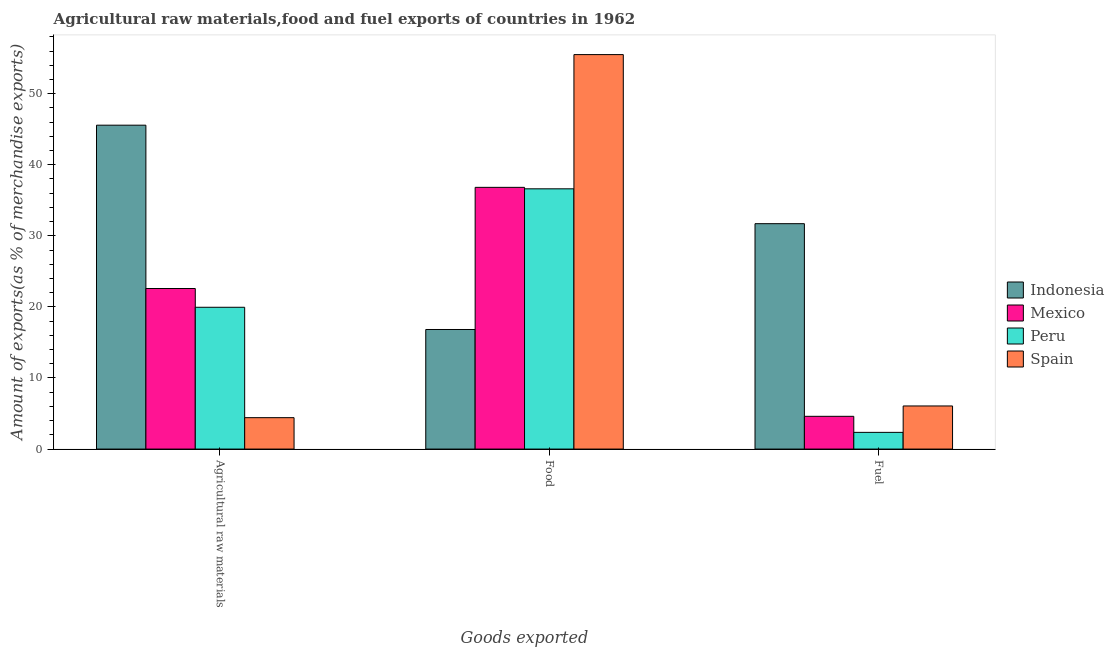How many groups of bars are there?
Your answer should be compact. 3. Are the number of bars per tick equal to the number of legend labels?
Give a very brief answer. Yes. How many bars are there on the 1st tick from the right?
Your answer should be very brief. 4. What is the label of the 2nd group of bars from the left?
Provide a short and direct response. Food. What is the percentage of fuel exports in Spain?
Provide a short and direct response. 6.07. Across all countries, what is the maximum percentage of food exports?
Keep it short and to the point. 55.5. Across all countries, what is the minimum percentage of raw materials exports?
Offer a very short reply. 4.42. In which country was the percentage of food exports minimum?
Offer a terse response. Indonesia. What is the total percentage of raw materials exports in the graph?
Make the answer very short. 92.53. What is the difference between the percentage of raw materials exports in Indonesia and that in Spain?
Ensure brevity in your answer.  41.15. What is the difference between the percentage of raw materials exports in Spain and the percentage of fuel exports in Indonesia?
Your answer should be compact. -27.29. What is the average percentage of fuel exports per country?
Offer a terse response. 11.18. What is the difference between the percentage of food exports and percentage of raw materials exports in Mexico?
Your response must be concise. 14.23. What is the ratio of the percentage of fuel exports in Peru to that in Mexico?
Provide a short and direct response. 0.51. Is the percentage of raw materials exports in Mexico less than that in Spain?
Ensure brevity in your answer.  No. What is the difference between the highest and the second highest percentage of raw materials exports?
Your answer should be compact. 22.98. What is the difference between the highest and the lowest percentage of fuel exports?
Keep it short and to the point. 29.36. In how many countries, is the percentage of food exports greater than the average percentage of food exports taken over all countries?
Ensure brevity in your answer.  3. Is the sum of the percentage of food exports in Mexico and Spain greater than the maximum percentage of raw materials exports across all countries?
Provide a succinct answer. Yes. How many countries are there in the graph?
Give a very brief answer. 4. What is the difference between two consecutive major ticks on the Y-axis?
Your response must be concise. 10. Are the values on the major ticks of Y-axis written in scientific E-notation?
Provide a succinct answer. No. Where does the legend appear in the graph?
Your answer should be compact. Center right. How many legend labels are there?
Give a very brief answer. 4. What is the title of the graph?
Provide a short and direct response. Agricultural raw materials,food and fuel exports of countries in 1962. Does "Turks and Caicos Islands" appear as one of the legend labels in the graph?
Make the answer very short. No. What is the label or title of the X-axis?
Your response must be concise. Goods exported. What is the label or title of the Y-axis?
Your answer should be very brief. Amount of exports(as % of merchandise exports). What is the Amount of exports(as % of merchandise exports) of Indonesia in Agricultural raw materials?
Offer a very short reply. 45.57. What is the Amount of exports(as % of merchandise exports) of Mexico in Agricultural raw materials?
Your answer should be very brief. 22.59. What is the Amount of exports(as % of merchandise exports) in Peru in Agricultural raw materials?
Your answer should be compact. 19.95. What is the Amount of exports(as % of merchandise exports) of Spain in Agricultural raw materials?
Offer a terse response. 4.42. What is the Amount of exports(as % of merchandise exports) of Indonesia in Food?
Your answer should be compact. 16.83. What is the Amount of exports(as % of merchandise exports) of Mexico in Food?
Make the answer very short. 36.82. What is the Amount of exports(as % of merchandise exports) in Peru in Food?
Offer a very short reply. 36.62. What is the Amount of exports(as % of merchandise exports) in Spain in Food?
Offer a terse response. 55.5. What is the Amount of exports(as % of merchandise exports) of Indonesia in Fuel?
Offer a very short reply. 31.71. What is the Amount of exports(as % of merchandise exports) of Mexico in Fuel?
Keep it short and to the point. 4.61. What is the Amount of exports(as % of merchandise exports) in Peru in Fuel?
Your answer should be very brief. 2.35. What is the Amount of exports(as % of merchandise exports) of Spain in Fuel?
Provide a short and direct response. 6.07. Across all Goods exported, what is the maximum Amount of exports(as % of merchandise exports) of Indonesia?
Make the answer very short. 45.57. Across all Goods exported, what is the maximum Amount of exports(as % of merchandise exports) in Mexico?
Ensure brevity in your answer.  36.82. Across all Goods exported, what is the maximum Amount of exports(as % of merchandise exports) in Peru?
Make the answer very short. 36.62. Across all Goods exported, what is the maximum Amount of exports(as % of merchandise exports) of Spain?
Your answer should be very brief. 55.5. Across all Goods exported, what is the minimum Amount of exports(as % of merchandise exports) of Indonesia?
Make the answer very short. 16.83. Across all Goods exported, what is the minimum Amount of exports(as % of merchandise exports) in Mexico?
Offer a terse response. 4.61. Across all Goods exported, what is the minimum Amount of exports(as % of merchandise exports) in Peru?
Your answer should be very brief. 2.35. Across all Goods exported, what is the minimum Amount of exports(as % of merchandise exports) in Spain?
Provide a short and direct response. 4.42. What is the total Amount of exports(as % of merchandise exports) of Indonesia in the graph?
Your answer should be very brief. 94.11. What is the total Amount of exports(as % of merchandise exports) in Mexico in the graph?
Ensure brevity in your answer.  64.02. What is the total Amount of exports(as % of merchandise exports) in Peru in the graph?
Offer a terse response. 58.92. What is the total Amount of exports(as % of merchandise exports) of Spain in the graph?
Give a very brief answer. 65.99. What is the difference between the Amount of exports(as % of merchandise exports) in Indonesia in Agricultural raw materials and that in Food?
Offer a very short reply. 28.74. What is the difference between the Amount of exports(as % of merchandise exports) in Mexico in Agricultural raw materials and that in Food?
Offer a very short reply. -14.23. What is the difference between the Amount of exports(as % of merchandise exports) of Peru in Agricultural raw materials and that in Food?
Ensure brevity in your answer.  -16.67. What is the difference between the Amount of exports(as % of merchandise exports) in Spain in Agricultural raw materials and that in Food?
Ensure brevity in your answer.  -51.08. What is the difference between the Amount of exports(as % of merchandise exports) in Indonesia in Agricultural raw materials and that in Fuel?
Make the answer very short. 13.86. What is the difference between the Amount of exports(as % of merchandise exports) in Mexico in Agricultural raw materials and that in Fuel?
Provide a succinct answer. 17.98. What is the difference between the Amount of exports(as % of merchandise exports) in Peru in Agricultural raw materials and that in Fuel?
Provide a succinct answer. 17.6. What is the difference between the Amount of exports(as % of merchandise exports) in Spain in Agricultural raw materials and that in Fuel?
Give a very brief answer. -1.65. What is the difference between the Amount of exports(as % of merchandise exports) of Indonesia in Food and that in Fuel?
Provide a short and direct response. -14.89. What is the difference between the Amount of exports(as % of merchandise exports) of Mexico in Food and that in Fuel?
Keep it short and to the point. 32.21. What is the difference between the Amount of exports(as % of merchandise exports) in Peru in Food and that in Fuel?
Give a very brief answer. 34.27. What is the difference between the Amount of exports(as % of merchandise exports) of Spain in Food and that in Fuel?
Your response must be concise. 49.43. What is the difference between the Amount of exports(as % of merchandise exports) in Indonesia in Agricultural raw materials and the Amount of exports(as % of merchandise exports) in Mexico in Food?
Your answer should be very brief. 8.75. What is the difference between the Amount of exports(as % of merchandise exports) in Indonesia in Agricultural raw materials and the Amount of exports(as % of merchandise exports) in Peru in Food?
Your response must be concise. 8.95. What is the difference between the Amount of exports(as % of merchandise exports) in Indonesia in Agricultural raw materials and the Amount of exports(as % of merchandise exports) in Spain in Food?
Provide a succinct answer. -9.93. What is the difference between the Amount of exports(as % of merchandise exports) in Mexico in Agricultural raw materials and the Amount of exports(as % of merchandise exports) in Peru in Food?
Your answer should be very brief. -14.03. What is the difference between the Amount of exports(as % of merchandise exports) in Mexico in Agricultural raw materials and the Amount of exports(as % of merchandise exports) in Spain in Food?
Give a very brief answer. -32.91. What is the difference between the Amount of exports(as % of merchandise exports) of Peru in Agricultural raw materials and the Amount of exports(as % of merchandise exports) of Spain in Food?
Provide a succinct answer. -35.55. What is the difference between the Amount of exports(as % of merchandise exports) in Indonesia in Agricultural raw materials and the Amount of exports(as % of merchandise exports) in Mexico in Fuel?
Provide a short and direct response. 40.96. What is the difference between the Amount of exports(as % of merchandise exports) in Indonesia in Agricultural raw materials and the Amount of exports(as % of merchandise exports) in Peru in Fuel?
Your response must be concise. 43.22. What is the difference between the Amount of exports(as % of merchandise exports) of Indonesia in Agricultural raw materials and the Amount of exports(as % of merchandise exports) of Spain in Fuel?
Your response must be concise. 39.5. What is the difference between the Amount of exports(as % of merchandise exports) of Mexico in Agricultural raw materials and the Amount of exports(as % of merchandise exports) of Peru in Fuel?
Your answer should be compact. 20.24. What is the difference between the Amount of exports(as % of merchandise exports) in Mexico in Agricultural raw materials and the Amount of exports(as % of merchandise exports) in Spain in Fuel?
Give a very brief answer. 16.52. What is the difference between the Amount of exports(as % of merchandise exports) in Peru in Agricultural raw materials and the Amount of exports(as % of merchandise exports) in Spain in Fuel?
Make the answer very short. 13.88. What is the difference between the Amount of exports(as % of merchandise exports) in Indonesia in Food and the Amount of exports(as % of merchandise exports) in Mexico in Fuel?
Provide a succinct answer. 12.22. What is the difference between the Amount of exports(as % of merchandise exports) of Indonesia in Food and the Amount of exports(as % of merchandise exports) of Peru in Fuel?
Your answer should be compact. 14.48. What is the difference between the Amount of exports(as % of merchandise exports) in Indonesia in Food and the Amount of exports(as % of merchandise exports) in Spain in Fuel?
Provide a short and direct response. 10.76. What is the difference between the Amount of exports(as % of merchandise exports) of Mexico in Food and the Amount of exports(as % of merchandise exports) of Peru in Fuel?
Provide a succinct answer. 34.47. What is the difference between the Amount of exports(as % of merchandise exports) of Mexico in Food and the Amount of exports(as % of merchandise exports) of Spain in Fuel?
Your response must be concise. 30.76. What is the difference between the Amount of exports(as % of merchandise exports) of Peru in Food and the Amount of exports(as % of merchandise exports) of Spain in Fuel?
Provide a short and direct response. 30.55. What is the average Amount of exports(as % of merchandise exports) in Indonesia per Goods exported?
Offer a terse response. 31.37. What is the average Amount of exports(as % of merchandise exports) of Mexico per Goods exported?
Make the answer very short. 21.34. What is the average Amount of exports(as % of merchandise exports) of Peru per Goods exported?
Offer a very short reply. 19.64. What is the average Amount of exports(as % of merchandise exports) in Spain per Goods exported?
Offer a very short reply. 22. What is the difference between the Amount of exports(as % of merchandise exports) in Indonesia and Amount of exports(as % of merchandise exports) in Mexico in Agricultural raw materials?
Your answer should be very brief. 22.98. What is the difference between the Amount of exports(as % of merchandise exports) of Indonesia and Amount of exports(as % of merchandise exports) of Peru in Agricultural raw materials?
Provide a short and direct response. 25.62. What is the difference between the Amount of exports(as % of merchandise exports) of Indonesia and Amount of exports(as % of merchandise exports) of Spain in Agricultural raw materials?
Ensure brevity in your answer.  41.15. What is the difference between the Amount of exports(as % of merchandise exports) in Mexico and Amount of exports(as % of merchandise exports) in Peru in Agricultural raw materials?
Offer a terse response. 2.64. What is the difference between the Amount of exports(as % of merchandise exports) in Mexico and Amount of exports(as % of merchandise exports) in Spain in Agricultural raw materials?
Your answer should be very brief. 18.17. What is the difference between the Amount of exports(as % of merchandise exports) of Peru and Amount of exports(as % of merchandise exports) of Spain in Agricultural raw materials?
Your answer should be very brief. 15.53. What is the difference between the Amount of exports(as % of merchandise exports) of Indonesia and Amount of exports(as % of merchandise exports) of Mexico in Food?
Give a very brief answer. -20. What is the difference between the Amount of exports(as % of merchandise exports) in Indonesia and Amount of exports(as % of merchandise exports) in Peru in Food?
Your answer should be compact. -19.79. What is the difference between the Amount of exports(as % of merchandise exports) in Indonesia and Amount of exports(as % of merchandise exports) in Spain in Food?
Keep it short and to the point. -38.68. What is the difference between the Amount of exports(as % of merchandise exports) of Mexico and Amount of exports(as % of merchandise exports) of Peru in Food?
Your response must be concise. 0.21. What is the difference between the Amount of exports(as % of merchandise exports) of Mexico and Amount of exports(as % of merchandise exports) of Spain in Food?
Provide a succinct answer. -18.68. What is the difference between the Amount of exports(as % of merchandise exports) in Peru and Amount of exports(as % of merchandise exports) in Spain in Food?
Give a very brief answer. -18.88. What is the difference between the Amount of exports(as % of merchandise exports) in Indonesia and Amount of exports(as % of merchandise exports) in Mexico in Fuel?
Your answer should be very brief. 27.1. What is the difference between the Amount of exports(as % of merchandise exports) of Indonesia and Amount of exports(as % of merchandise exports) of Peru in Fuel?
Offer a terse response. 29.36. What is the difference between the Amount of exports(as % of merchandise exports) in Indonesia and Amount of exports(as % of merchandise exports) in Spain in Fuel?
Ensure brevity in your answer.  25.65. What is the difference between the Amount of exports(as % of merchandise exports) of Mexico and Amount of exports(as % of merchandise exports) of Peru in Fuel?
Provide a succinct answer. 2.26. What is the difference between the Amount of exports(as % of merchandise exports) of Mexico and Amount of exports(as % of merchandise exports) of Spain in Fuel?
Ensure brevity in your answer.  -1.46. What is the difference between the Amount of exports(as % of merchandise exports) in Peru and Amount of exports(as % of merchandise exports) in Spain in Fuel?
Provide a succinct answer. -3.72. What is the ratio of the Amount of exports(as % of merchandise exports) in Indonesia in Agricultural raw materials to that in Food?
Your answer should be compact. 2.71. What is the ratio of the Amount of exports(as % of merchandise exports) in Mexico in Agricultural raw materials to that in Food?
Offer a terse response. 0.61. What is the ratio of the Amount of exports(as % of merchandise exports) in Peru in Agricultural raw materials to that in Food?
Offer a terse response. 0.54. What is the ratio of the Amount of exports(as % of merchandise exports) of Spain in Agricultural raw materials to that in Food?
Keep it short and to the point. 0.08. What is the ratio of the Amount of exports(as % of merchandise exports) of Indonesia in Agricultural raw materials to that in Fuel?
Provide a succinct answer. 1.44. What is the ratio of the Amount of exports(as % of merchandise exports) in Mexico in Agricultural raw materials to that in Fuel?
Provide a succinct answer. 4.9. What is the ratio of the Amount of exports(as % of merchandise exports) in Peru in Agricultural raw materials to that in Fuel?
Give a very brief answer. 8.49. What is the ratio of the Amount of exports(as % of merchandise exports) in Spain in Agricultural raw materials to that in Fuel?
Offer a very short reply. 0.73. What is the ratio of the Amount of exports(as % of merchandise exports) of Indonesia in Food to that in Fuel?
Ensure brevity in your answer.  0.53. What is the ratio of the Amount of exports(as % of merchandise exports) of Mexico in Food to that in Fuel?
Provide a succinct answer. 7.99. What is the ratio of the Amount of exports(as % of merchandise exports) in Peru in Food to that in Fuel?
Provide a short and direct response. 15.58. What is the ratio of the Amount of exports(as % of merchandise exports) of Spain in Food to that in Fuel?
Give a very brief answer. 9.15. What is the difference between the highest and the second highest Amount of exports(as % of merchandise exports) of Indonesia?
Your response must be concise. 13.86. What is the difference between the highest and the second highest Amount of exports(as % of merchandise exports) in Mexico?
Your response must be concise. 14.23. What is the difference between the highest and the second highest Amount of exports(as % of merchandise exports) of Peru?
Ensure brevity in your answer.  16.67. What is the difference between the highest and the second highest Amount of exports(as % of merchandise exports) in Spain?
Ensure brevity in your answer.  49.43. What is the difference between the highest and the lowest Amount of exports(as % of merchandise exports) in Indonesia?
Your answer should be very brief. 28.74. What is the difference between the highest and the lowest Amount of exports(as % of merchandise exports) in Mexico?
Offer a terse response. 32.21. What is the difference between the highest and the lowest Amount of exports(as % of merchandise exports) in Peru?
Offer a very short reply. 34.27. What is the difference between the highest and the lowest Amount of exports(as % of merchandise exports) in Spain?
Make the answer very short. 51.08. 